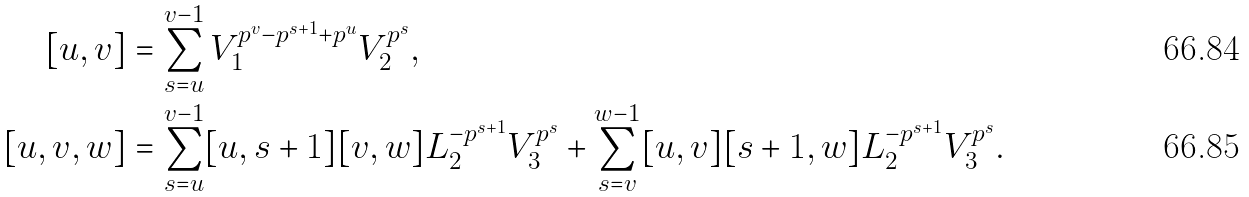Convert formula to latex. <formula><loc_0><loc_0><loc_500><loc_500>[ u , v ] & = \sum _ { s = u } ^ { v - 1 } V _ { 1 } ^ { p ^ { v } - p ^ { s + 1 } + p ^ { u } } V _ { 2 } ^ { p ^ { s } } , \\ { [ u , v , w ] } & = \sum _ { s = u } ^ { v - 1 } [ u , s + 1 ] [ v , w ] L _ { 2 } ^ { - p ^ { s + 1 } } V _ { 3 } ^ { p ^ { s } } + \sum _ { s = v } ^ { w - 1 } [ u , v ] [ s + 1 , w ] L _ { 2 } ^ { - p ^ { s + 1 } } V _ { 3 } ^ { p ^ { s } } .</formula> 